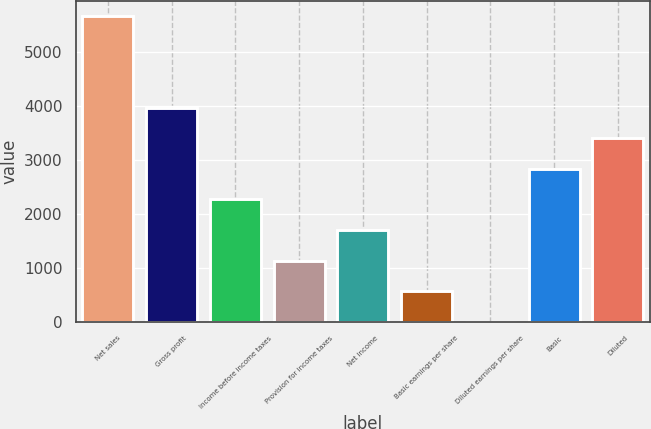<chart> <loc_0><loc_0><loc_500><loc_500><bar_chart><fcel>Net sales<fcel>Gross profit<fcel>Income before income taxes<fcel>Provision for income taxes<fcel>Net income<fcel>Basic earnings per share<fcel>Diluted earnings per share<fcel>Basic<fcel>Diluted<nl><fcel>5673<fcel>3971.23<fcel>2269.48<fcel>1134.98<fcel>1702.23<fcel>567.73<fcel>0.48<fcel>2836.73<fcel>3403.98<nl></chart> 